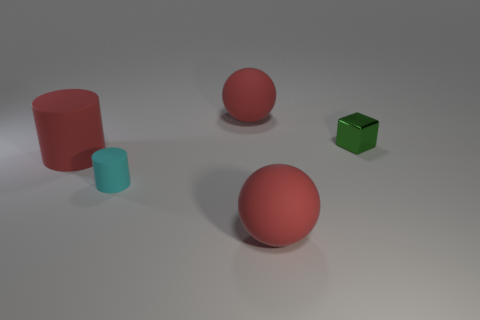There is a red matte thing that is both behind the small cyan cylinder and in front of the tiny green block; how big is it?
Keep it short and to the point. Large. There is a large object that is in front of the tiny green metallic block and right of the large red rubber cylinder; what color is it?
Your answer should be very brief. Red. What number of big objects are either cyan matte cylinders or rubber balls?
Provide a short and direct response. 2. What is the size of the red rubber object that is the same shape as the cyan matte thing?
Your answer should be very brief. Large. The small metal thing has what shape?
Offer a very short reply. Cube. Do the red cylinder and the tiny block that is to the right of the cyan rubber object have the same material?
Offer a very short reply. No. How many matte objects are small blocks or red spheres?
Your answer should be very brief. 2. There is a cyan thing that is in front of the metallic block; what size is it?
Offer a terse response. Small. The other cylinder that is made of the same material as the red cylinder is what size?
Offer a very short reply. Small. How many small matte cylinders have the same color as the big cylinder?
Offer a terse response. 0. 